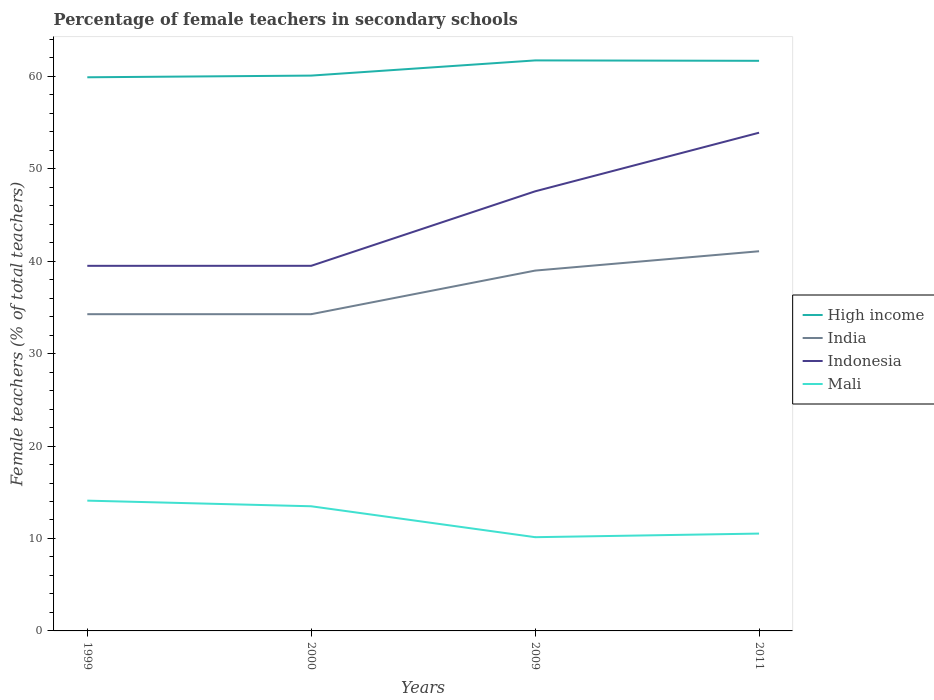Across all years, what is the maximum percentage of female teachers in Mali?
Your response must be concise. 10.14. What is the total percentage of female teachers in High income in the graph?
Provide a succinct answer. -0.18. What is the difference between the highest and the second highest percentage of female teachers in Mali?
Offer a very short reply. 3.95. What is the difference between the highest and the lowest percentage of female teachers in Mali?
Your answer should be very brief. 2. Is the percentage of female teachers in High income strictly greater than the percentage of female teachers in Indonesia over the years?
Offer a very short reply. No. How many lines are there?
Make the answer very short. 4. Does the graph contain any zero values?
Offer a very short reply. No. Does the graph contain grids?
Your answer should be very brief. No. Where does the legend appear in the graph?
Your answer should be very brief. Center right. What is the title of the graph?
Your answer should be compact. Percentage of female teachers in secondary schools. What is the label or title of the X-axis?
Ensure brevity in your answer.  Years. What is the label or title of the Y-axis?
Ensure brevity in your answer.  Female teachers (% of total teachers). What is the Female teachers (% of total teachers) in High income in 1999?
Your response must be concise. 59.89. What is the Female teachers (% of total teachers) of India in 1999?
Ensure brevity in your answer.  34.26. What is the Female teachers (% of total teachers) of Indonesia in 1999?
Make the answer very short. 39.49. What is the Female teachers (% of total teachers) in Mali in 1999?
Provide a succinct answer. 14.09. What is the Female teachers (% of total teachers) in High income in 2000?
Provide a short and direct response. 60.08. What is the Female teachers (% of total teachers) of India in 2000?
Your response must be concise. 34.26. What is the Female teachers (% of total teachers) in Indonesia in 2000?
Provide a succinct answer. 39.5. What is the Female teachers (% of total teachers) of Mali in 2000?
Ensure brevity in your answer.  13.48. What is the Female teachers (% of total teachers) of High income in 2009?
Your response must be concise. 61.72. What is the Female teachers (% of total teachers) in India in 2009?
Offer a terse response. 38.98. What is the Female teachers (% of total teachers) in Indonesia in 2009?
Provide a succinct answer. 47.56. What is the Female teachers (% of total teachers) of Mali in 2009?
Offer a very short reply. 10.14. What is the Female teachers (% of total teachers) of High income in 2011?
Provide a succinct answer. 61.67. What is the Female teachers (% of total teachers) of India in 2011?
Offer a terse response. 41.07. What is the Female teachers (% of total teachers) in Indonesia in 2011?
Provide a succinct answer. 53.9. What is the Female teachers (% of total teachers) of Mali in 2011?
Provide a succinct answer. 10.53. Across all years, what is the maximum Female teachers (% of total teachers) of High income?
Keep it short and to the point. 61.72. Across all years, what is the maximum Female teachers (% of total teachers) of India?
Provide a short and direct response. 41.07. Across all years, what is the maximum Female teachers (% of total teachers) of Indonesia?
Ensure brevity in your answer.  53.9. Across all years, what is the maximum Female teachers (% of total teachers) in Mali?
Ensure brevity in your answer.  14.09. Across all years, what is the minimum Female teachers (% of total teachers) in High income?
Offer a terse response. 59.89. Across all years, what is the minimum Female teachers (% of total teachers) in India?
Your response must be concise. 34.26. Across all years, what is the minimum Female teachers (% of total teachers) in Indonesia?
Keep it short and to the point. 39.49. Across all years, what is the minimum Female teachers (% of total teachers) of Mali?
Your answer should be very brief. 10.14. What is the total Female teachers (% of total teachers) in High income in the graph?
Ensure brevity in your answer.  243.36. What is the total Female teachers (% of total teachers) of India in the graph?
Your answer should be compact. 148.58. What is the total Female teachers (% of total teachers) of Indonesia in the graph?
Offer a terse response. 180.45. What is the total Female teachers (% of total teachers) of Mali in the graph?
Offer a very short reply. 48.25. What is the difference between the Female teachers (% of total teachers) of High income in 1999 and that in 2000?
Offer a very short reply. -0.18. What is the difference between the Female teachers (% of total teachers) of India in 1999 and that in 2000?
Your response must be concise. -0. What is the difference between the Female teachers (% of total teachers) of Indonesia in 1999 and that in 2000?
Make the answer very short. -0. What is the difference between the Female teachers (% of total teachers) of Mali in 1999 and that in 2000?
Your response must be concise. 0.61. What is the difference between the Female teachers (% of total teachers) in High income in 1999 and that in 2009?
Provide a short and direct response. -1.82. What is the difference between the Female teachers (% of total teachers) in India in 1999 and that in 2009?
Ensure brevity in your answer.  -4.72. What is the difference between the Female teachers (% of total teachers) of Indonesia in 1999 and that in 2009?
Your answer should be very brief. -8.06. What is the difference between the Female teachers (% of total teachers) in Mali in 1999 and that in 2009?
Give a very brief answer. 3.95. What is the difference between the Female teachers (% of total teachers) in High income in 1999 and that in 2011?
Your answer should be compact. -1.78. What is the difference between the Female teachers (% of total teachers) of India in 1999 and that in 2011?
Make the answer very short. -6.81. What is the difference between the Female teachers (% of total teachers) in Indonesia in 1999 and that in 2011?
Provide a succinct answer. -14.4. What is the difference between the Female teachers (% of total teachers) in Mali in 1999 and that in 2011?
Your response must be concise. 3.56. What is the difference between the Female teachers (% of total teachers) of High income in 2000 and that in 2009?
Offer a very short reply. -1.64. What is the difference between the Female teachers (% of total teachers) of India in 2000 and that in 2009?
Keep it short and to the point. -4.72. What is the difference between the Female teachers (% of total teachers) of Indonesia in 2000 and that in 2009?
Give a very brief answer. -8.06. What is the difference between the Female teachers (% of total teachers) in Mali in 2000 and that in 2009?
Ensure brevity in your answer.  3.34. What is the difference between the Female teachers (% of total teachers) in High income in 2000 and that in 2011?
Keep it short and to the point. -1.6. What is the difference between the Female teachers (% of total teachers) in India in 2000 and that in 2011?
Offer a very short reply. -6.81. What is the difference between the Female teachers (% of total teachers) of Indonesia in 2000 and that in 2011?
Give a very brief answer. -14.4. What is the difference between the Female teachers (% of total teachers) of Mali in 2000 and that in 2011?
Provide a succinct answer. 2.95. What is the difference between the Female teachers (% of total teachers) of High income in 2009 and that in 2011?
Your answer should be compact. 0.04. What is the difference between the Female teachers (% of total teachers) in India in 2009 and that in 2011?
Keep it short and to the point. -2.09. What is the difference between the Female teachers (% of total teachers) of Indonesia in 2009 and that in 2011?
Provide a succinct answer. -6.34. What is the difference between the Female teachers (% of total teachers) of Mali in 2009 and that in 2011?
Give a very brief answer. -0.39. What is the difference between the Female teachers (% of total teachers) of High income in 1999 and the Female teachers (% of total teachers) of India in 2000?
Offer a very short reply. 25.63. What is the difference between the Female teachers (% of total teachers) in High income in 1999 and the Female teachers (% of total teachers) in Indonesia in 2000?
Ensure brevity in your answer.  20.4. What is the difference between the Female teachers (% of total teachers) in High income in 1999 and the Female teachers (% of total teachers) in Mali in 2000?
Offer a terse response. 46.41. What is the difference between the Female teachers (% of total teachers) in India in 1999 and the Female teachers (% of total teachers) in Indonesia in 2000?
Keep it short and to the point. -5.23. What is the difference between the Female teachers (% of total teachers) in India in 1999 and the Female teachers (% of total teachers) in Mali in 2000?
Provide a short and direct response. 20.78. What is the difference between the Female teachers (% of total teachers) in Indonesia in 1999 and the Female teachers (% of total teachers) in Mali in 2000?
Provide a succinct answer. 26.01. What is the difference between the Female teachers (% of total teachers) in High income in 1999 and the Female teachers (% of total teachers) in India in 2009?
Ensure brevity in your answer.  20.91. What is the difference between the Female teachers (% of total teachers) of High income in 1999 and the Female teachers (% of total teachers) of Indonesia in 2009?
Offer a terse response. 12.34. What is the difference between the Female teachers (% of total teachers) in High income in 1999 and the Female teachers (% of total teachers) in Mali in 2009?
Give a very brief answer. 49.75. What is the difference between the Female teachers (% of total teachers) of India in 1999 and the Female teachers (% of total teachers) of Indonesia in 2009?
Your response must be concise. -13.29. What is the difference between the Female teachers (% of total teachers) in India in 1999 and the Female teachers (% of total teachers) in Mali in 2009?
Offer a terse response. 24.12. What is the difference between the Female teachers (% of total teachers) of Indonesia in 1999 and the Female teachers (% of total teachers) of Mali in 2009?
Provide a short and direct response. 29.35. What is the difference between the Female teachers (% of total teachers) of High income in 1999 and the Female teachers (% of total teachers) of India in 2011?
Provide a succinct answer. 18.82. What is the difference between the Female teachers (% of total teachers) of High income in 1999 and the Female teachers (% of total teachers) of Indonesia in 2011?
Provide a short and direct response. 6. What is the difference between the Female teachers (% of total teachers) in High income in 1999 and the Female teachers (% of total teachers) in Mali in 2011?
Ensure brevity in your answer.  49.36. What is the difference between the Female teachers (% of total teachers) in India in 1999 and the Female teachers (% of total teachers) in Indonesia in 2011?
Provide a succinct answer. -19.63. What is the difference between the Female teachers (% of total teachers) in India in 1999 and the Female teachers (% of total teachers) in Mali in 2011?
Provide a short and direct response. 23.73. What is the difference between the Female teachers (% of total teachers) of Indonesia in 1999 and the Female teachers (% of total teachers) of Mali in 2011?
Offer a very short reply. 28.96. What is the difference between the Female teachers (% of total teachers) in High income in 2000 and the Female teachers (% of total teachers) in India in 2009?
Offer a terse response. 21.09. What is the difference between the Female teachers (% of total teachers) in High income in 2000 and the Female teachers (% of total teachers) in Indonesia in 2009?
Offer a terse response. 12.52. What is the difference between the Female teachers (% of total teachers) of High income in 2000 and the Female teachers (% of total teachers) of Mali in 2009?
Keep it short and to the point. 49.93. What is the difference between the Female teachers (% of total teachers) in India in 2000 and the Female teachers (% of total teachers) in Indonesia in 2009?
Offer a terse response. -13.29. What is the difference between the Female teachers (% of total teachers) of India in 2000 and the Female teachers (% of total teachers) of Mali in 2009?
Offer a terse response. 24.12. What is the difference between the Female teachers (% of total teachers) in Indonesia in 2000 and the Female teachers (% of total teachers) in Mali in 2009?
Give a very brief answer. 29.36. What is the difference between the Female teachers (% of total teachers) of High income in 2000 and the Female teachers (% of total teachers) of India in 2011?
Your answer should be very brief. 19. What is the difference between the Female teachers (% of total teachers) of High income in 2000 and the Female teachers (% of total teachers) of Indonesia in 2011?
Keep it short and to the point. 6.18. What is the difference between the Female teachers (% of total teachers) in High income in 2000 and the Female teachers (% of total teachers) in Mali in 2011?
Provide a succinct answer. 49.55. What is the difference between the Female teachers (% of total teachers) of India in 2000 and the Female teachers (% of total teachers) of Indonesia in 2011?
Your answer should be very brief. -19.63. What is the difference between the Female teachers (% of total teachers) of India in 2000 and the Female teachers (% of total teachers) of Mali in 2011?
Ensure brevity in your answer.  23.73. What is the difference between the Female teachers (% of total teachers) in Indonesia in 2000 and the Female teachers (% of total teachers) in Mali in 2011?
Ensure brevity in your answer.  28.97. What is the difference between the Female teachers (% of total teachers) of High income in 2009 and the Female teachers (% of total teachers) of India in 2011?
Keep it short and to the point. 20.64. What is the difference between the Female teachers (% of total teachers) of High income in 2009 and the Female teachers (% of total teachers) of Indonesia in 2011?
Offer a very short reply. 7.82. What is the difference between the Female teachers (% of total teachers) of High income in 2009 and the Female teachers (% of total teachers) of Mali in 2011?
Your answer should be very brief. 51.19. What is the difference between the Female teachers (% of total teachers) of India in 2009 and the Female teachers (% of total teachers) of Indonesia in 2011?
Keep it short and to the point. -14.92. What is the difference between the Female teachers (% of total teachers) of India in 2009 and the Female teachers (% of total teachers) of Mali in 2011?
Provide a short and direct response. 28.45. What is the difference between the Female teachers (% of total teachers) of Indonesia in 2009 and the Female teachers (% of total teachers) of Mali in 2011?
Offer a very short reply. 37.03. What is the average Female teachers (% of total teachers) in High income per year?
Provide a succinct answer. 60.84. What is the average Female teachers (% of total teachers) in India per year?
Offer a terse response. 37.15. What is the average Female teachers (% of total teachers) in Indonesia per year?
Ensure brevity in your answer.  45.11. What is the average Female teachers (% of total teachers) of Mali per year?
Your response must be concise. 12.06. In the year 1999, what is the difference between the Female teachers (% of total teachers) of High income and Female teachers (% of total teachers) of India?
Ensure brevity in your answer.  25.63. In the year 1999, what is the difference between the Female teachers (% of total teachers) of High income and Female teachers (% of total teachers) of Indonesia?
Your answer should be very brief. 20.4. In the year 1999, what is the difference between the Female teachers (% of total teachers) of High income and Female teachers (% of total teachers) of Mali?
Your answer should be very brief. 45.8. In the year 1999, what is the difference between the Female teachers (% of total teachers) of India and Female teachers (% of total teachers) of Indonesia?
Your response must be concise. -5.23. In the year 1999, what is the difference between the Female teachers (% of total teachers) of India and Female teachers (% of total teachers) of Mali?
Provide a short and direct response. 20.17. In the year 1999, what is the difference between the Female teachers (% of total teachers) in Indonesia and Female teachers (% of total teachers) in Mali?
Keep it short and to the point. 25.4. In the year 2000, what is the difference between the Female teachers (% of total teachers) in High income and Female teachers (% of total teachers) in India?
Offer a terse response. 25.81. In the year 2000, what is the difference between the Female teachers (% of total teachers) in High income and Female teachers (% of total teachers) in Indonesia?
Provide a succinct answer. 20.58. In the year 2000, what is the difference between the Female teachers (% of total teachers) of High income and Female teachers (% of total teachers) of Mali?
Keep it short and to the point. 46.59. In the year 2000, what is the difference between the Female teachers (% of total teachers) in India and Female teachers (% of total teachers) in Indonesia?
Your answer should be very brief. -5.23. In the year 2000, what is the difference between the Female teachers (% of total teachers) in India and Female teachers (% of total teachers) in Mali?
Keep it short and to the point. 20.78. In the year 2000, what is the difference between the Female teachers (% of total teachers) in Indonesia and Female teachers (% of total teachers) in Mali?
Offer a terse response. 26.01. In the year 2009, what is the difference between the Female teachers (% of total teachers) in High income and Female teachers (% of total teachers) in India?
Make the answer very short. 22.74. In the year 2009, what is the difference between the Female teachers (% of total teachers) in High income and Female teachers (% of total teachers) in Indonesia?
Ensure brevity in your answer.  14.16. In the year 2009, what is the difference between the Female teachers (% of total teachers) of High income and Female teachers (% of total teachers) of Mali?
Your answer should be compact. 51.58. In the year 2009, what is the difference between the Female teachers (% of total teachers) of India and Female teachers (% of total teachers) of Indonesia?
Ensure brevity in your answer.  -8.58. In the year 2009, what is the difference between the Female teachers (% of total teachers) of India and Female teachers (% of total teachers) of Mali?
Offer a terse response. 28.84. In the year 2009, what is the difference between the Female teachers (% of total teachers) of Indonesia and Female teachers (% of total teachers) of Mali?
Make the answer very short. 37.42. In the year 2011, what is the difference between the Female teachers (% of total teachers) of High income and Female teachers (% of total teachers) of India?
Your response must be concise. 20.6. In the year 2011, what is the difference between the Female teachers (% of total teachers) of High income and Female teachers (% of total teachers) of Indonesia?
Your answer should be compact. 7.78. In the year 2011, what is the difference between the Female teachers (% of total teachers) of High income and Female teachers (% of total teachers) of Mali?
Your answer should be compact. 51.14. In the year 2011, what is the difference between the Female teachers (% of total teachers) in India and Female teachers (% of total teachers) in Indonesia?
Ensure brevity in your answer.  -12.82. In the year 2011, what is the difference between the Female teachers (% of total teachers) in India and Female teachers (% of total teachers) in Mali?
Give a very brief answer. 30.54. In the year 2011, what is the difference between the Female teachers (% of total teachers) in Indonesia and Female teachers (% of total teachers) in Mali?
Give a very brief answer. 43.37. What is the ratio of the Female teachers (% of total teachers) in Mali in 1999 to that in 2000?
Give a very brief answer. 1.05. What is the ratio of the Female teachers (% of total teachers) of High income in 1999 to that in 2009?
Your response must be concise. 0.97. What is the ratio of the Female teachers (% of total teachers) of India in 1999 to that in 2009?
Your answer should be compact. 0.88. What is the ratio of the Female teachers (% of total teachers) of Indonesia in 1999 to that in 2009?
Your response must be concise. 0.83. What is the ratio of the Female teachers (% of total teachers) in Mali in 1999 to that in 2009?
Your answer should be compact. 1.39. What is the ratio of the Female teachers (% of total teachers) of High income in 1999 to that in 2011?
Offer a terse response. 0.97. What is the ratio of the Female teachers (% of total teachers) in India in 1999 to that in 2011?
Ensure brevity in your answer.  0.83. What is the ratio of the Female teachers (% of total teachers) in Indonesia in 1999 to that in 2011?
Your answer should be compact. 0.73. What is the ratio of the Female teachers (% of total teachers) in Mali in 1999 to that in 2011?
Keep it short and to the point. 1.34. What is the ratio of the Female teachers (% of total teachers) of High income in 2000 to that in 2009?
Your answer should be compact. 0.97. What is the ratio of the Female teachers (% of total teachers) of India in 2000 to that in 2009?
Offer a very short reply. 0.88. What is the ratio of the Female teachers (% of total teachers) of Indonesia in 2000 to that in 2009?
Keep it short and to the point. 0.83. What is the ratio of the Female teachers (% of total teachers) of Mali in 2000 to that in 2009?
Provide a short and direct response. 1.33. What is the ratio of the Female teachers (% of total teachers) in High income in 2000 to that in 2011?
Your answer should be very brief. 0.97. What is the ratio of the Female teachers (% of total teachers) of India in 2000 to that in 2011?
Provide a succinct answer. 0.83. What is the ratio of the Female teachers (% of total teachers) in Indonesia in 2000 to that in 2011?
Offer a terse response. 0.73. What is the ratio of the Female teachers (% of total teachers) of Mali in 2000 to that in 2011?
Make the answer very short. 1.28. What is the ratio of the Female teachers (% of total teachers) of High income in 2009 to that in 2011?
Provide a short and direct response. 1. What is the ratio of the Female teachers (% of total teachers) in India in 2009 to that in 2011?
Keep it short and to the point. 0.95. What is the ratio of the Female teachers (% of total teachers) of Indonesia in 2009 to that in 2011?
Your answer should be compact. 0.88. What is the ratio of the Female teachers (% of total teachers) in Mali in 2009 to that in 2011?
Provide a short and direct response. 0.96. What is the difference between the highest and the second highest Female teachers (% of total teachers) in High income?
Offer a terse response. 0.04. What is the difference between the highest and the second highest Female teachers (% of total teachers) in India?
Provide a succinct answer. 2.09. What is the difference between the highest and the second highest Female teachers (% of total teachers) in Indonesia?
Your response must be concise. 6.34. What is the difference between the highest and the second highest Female teachers (% of total teachers) of Mali?
Offer a very short reply. 0.61. What is the difference between the highest and the lowest Female teachers (% of total teachers) of High income?
Keep it short and to the point. 1.82. What is the difference between the highest and the lowest Female teachers (% of total teachers) in India?
Offer a very short reply. 6.81. What is the difference between the highest and the lowest Female teachers (% of total teachers) of Indonesia?
Offer a terse response. 14.4. What is the difference between the highest and the lowest Female teachers (% of total teachers) in Mali?
Offer a terse response. 3.95. 